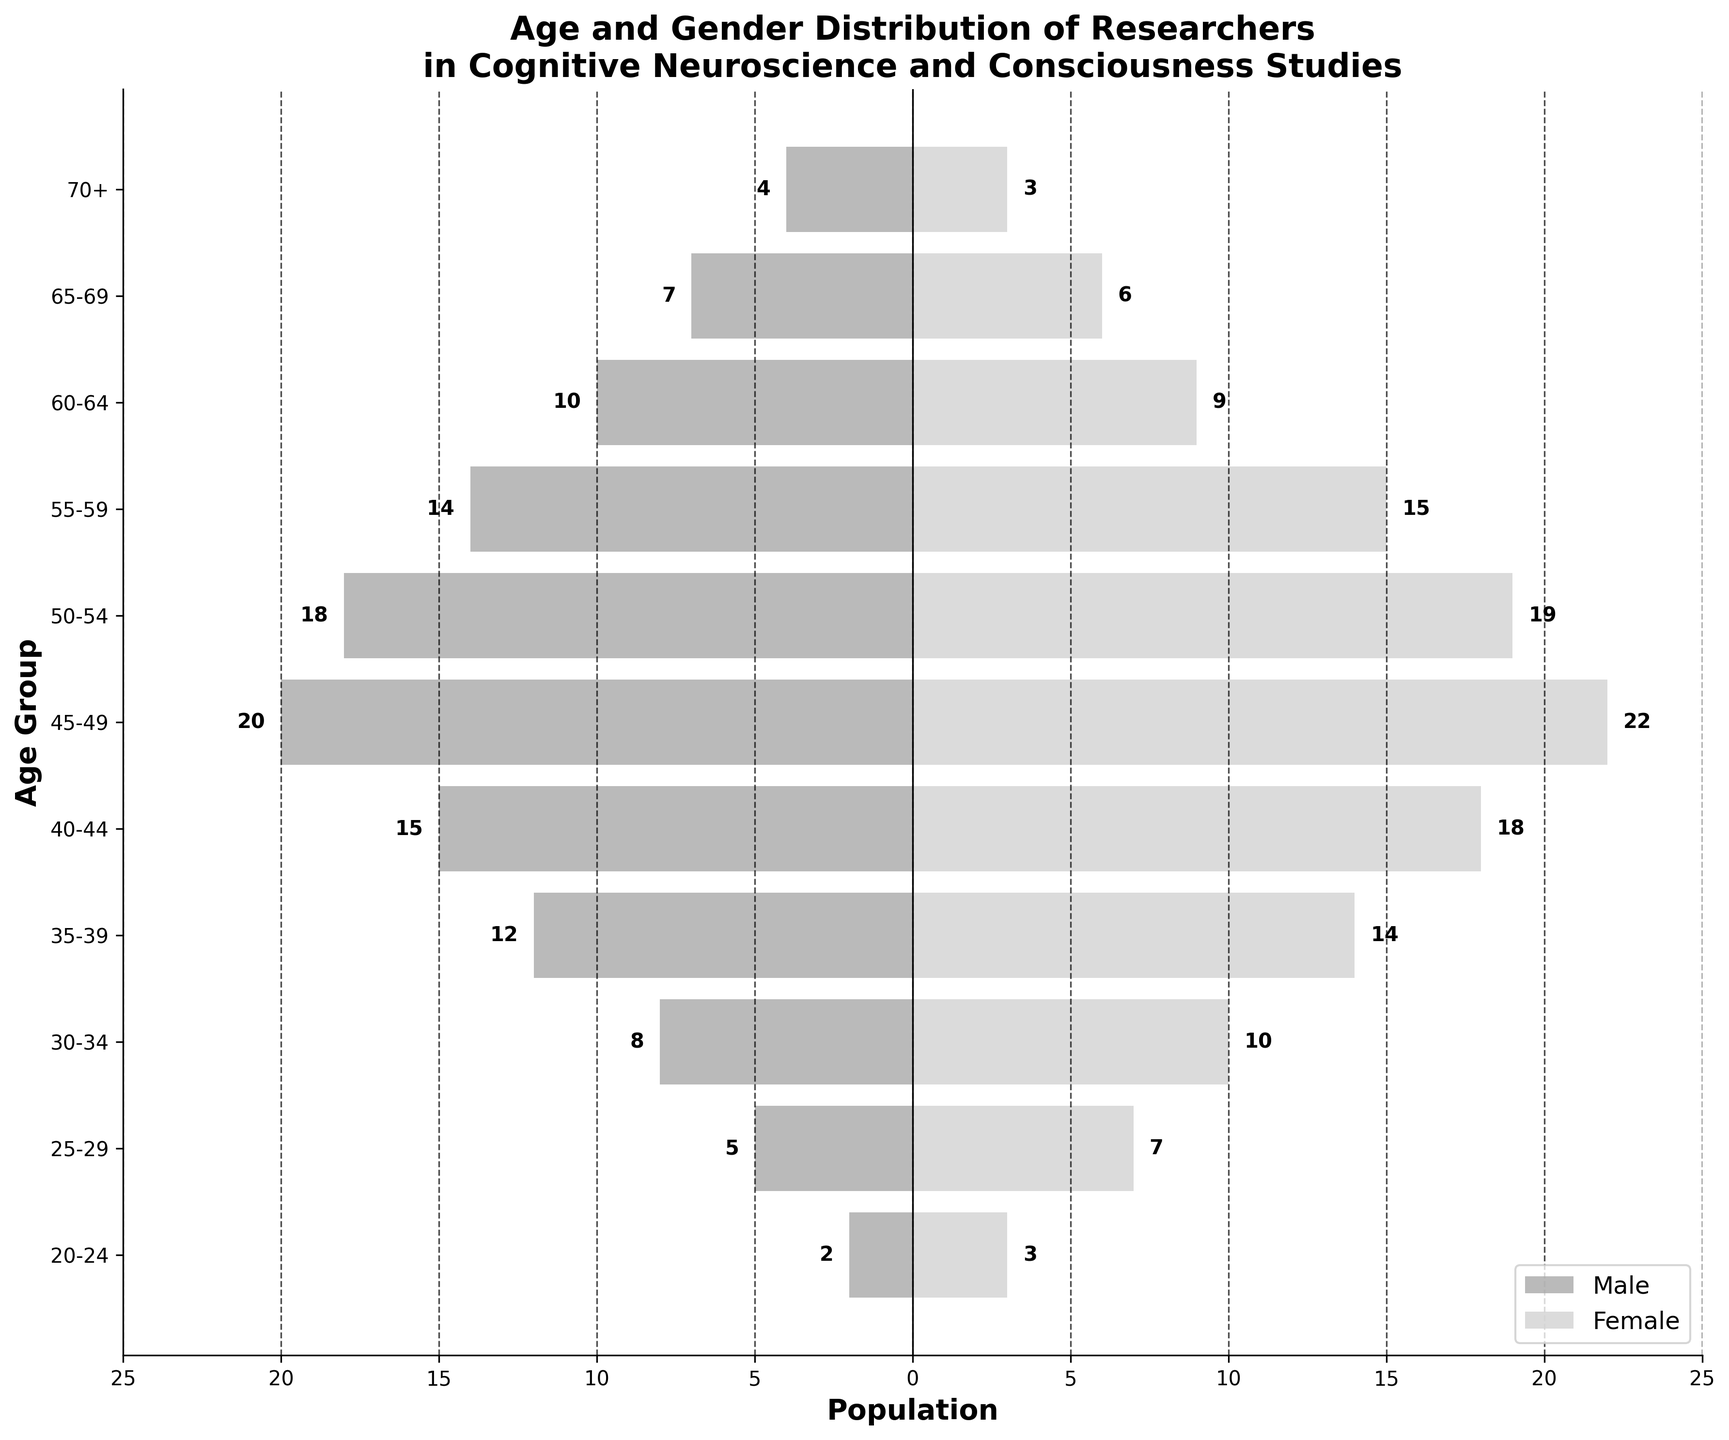What's the total number of male researchers in the 45-49 age group? Count the number of male researchers in the specified age group by looking at the '45-49' bar on the left side of the pyramid.
Answer: 20 Which age group has the highest number of female researchers? Identify the age group with the tallest bar on the right side of the pyramid and check the corresponding age label. The 45-49 age group has the highest bar for females.
Answer: 45-49 How does the number of male researchers in the 55-59 age group compare to the number of female researchers in the same group? Find the '55-59' age group bars, compare the length of the bars for males and females, and verify the counts. Males have 14 researchers, while females have 15.
Answer: Females have 1 more researcher than males What is the total number of researchers aged 25-29? Sum the number of male and female researchers in the 25-29 age group by adding both bars' values.
Answer: 12 In which age group is the gender distribution almost equal? Examine the lengths of the bars for both genders and note where the difference is minimal. The '50-54' age group has a close count with 18 males and 19 females.
Answer: 50-54 What is the age group with the smallest number of researchers? Identify the shortest bars on both sides of the pyramid and check the corresponding age label. Both bars for the '70+' group are the shortest.
Answer: 70+ Compare the number of researchers in the 40-44 age group to those in the 65-69 age group. Sum the researchers (male and female) in both age groups separately and compare the totals. For 40-44, the total is 33 (15 males + 18 females). For 65-69, the total is 13 (7 males + 6 females).
Answer: 40-44 has more researchers What's the difference in the number of male and female researchers in the 30-34 age group? Subtract the number of males from the number of females in the 30-34 age group. Females have 10 researchers compared to 8 males.
Answer: 2 more females Which side of the age distribution pyramid appears more balanced between genders across most age groups? Visually assess which side (left for males or right for females) often shows similar lengths of bars across different age groups. Overall, the female side appears more balanced.
Answer: Female side What is the gender distribution trend among older researchers (60+)? Observe the bars' lengths for older age groups (60-64, 65-69, 70+). Both genders show a decrement trend, but males generally have higher counts.
Answer: Decreasing trend for both, more males 